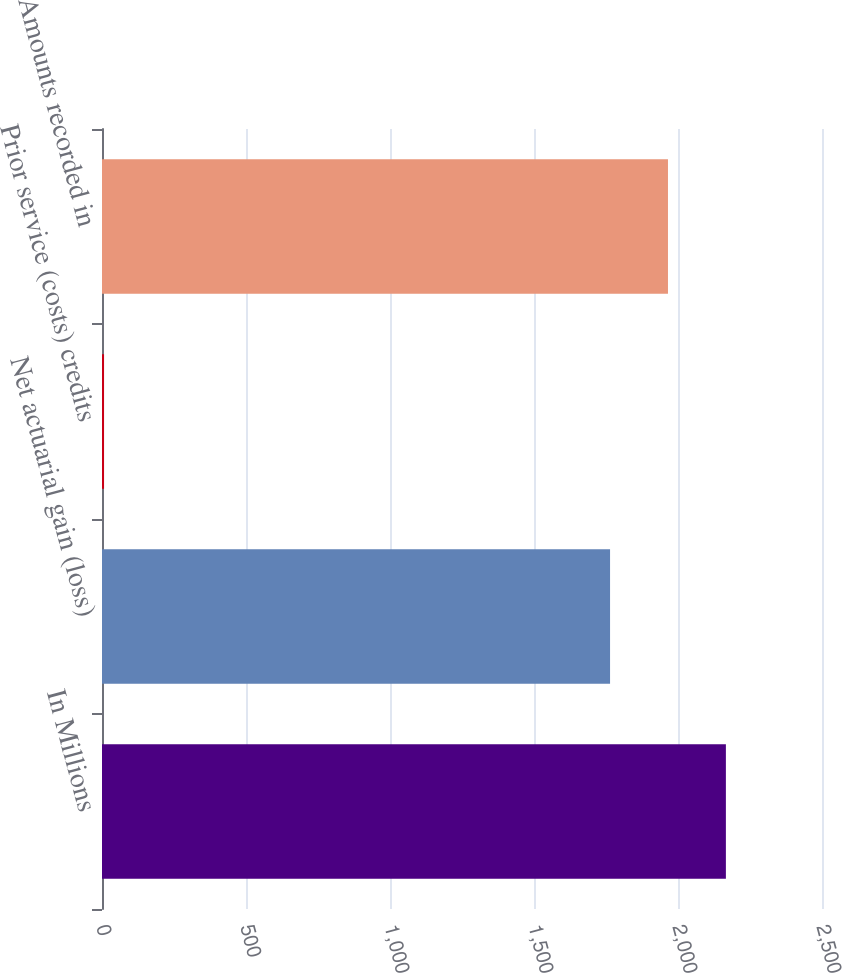<chart> <loc_0><loc_0><loc_500><loc_500><bar_chart><fcel>In Millions<fcel>Net actuarial gain (loss)<fcel>Prior service (costs) credits<fcel>Amounts recorded in<nl><fcel>2166.28<fcel>1764.1<fcel>7.1<fcel>1965.19<nl></chart> 